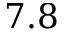<formula> <loc_0><loc_0><loc_500><loc_500>7 . 8</formula> 